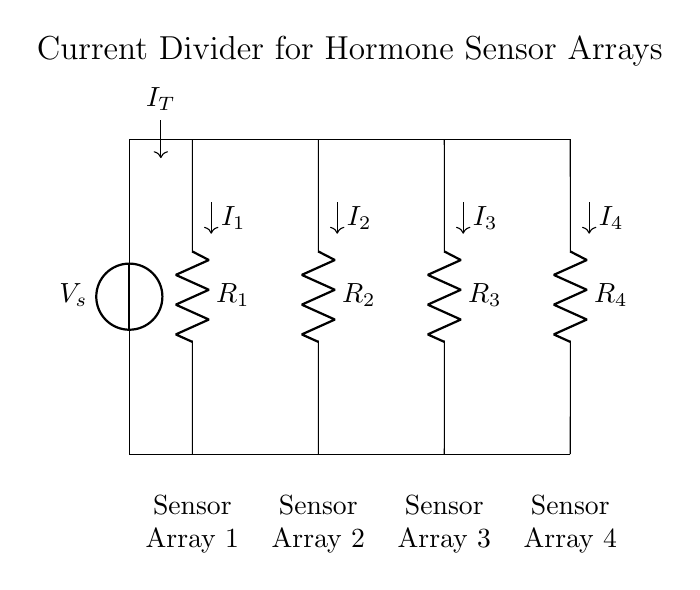What is the total input current in this circuit? The total input current, denoted as It, is the current flowing from the voltage source into the circuit. It is indicated by the arrow labeled I_T.
Answer: I_T What are the resistance values in this circuit? The resistors are labeled R_1, R_2, R_3, and R_4. However, the specific numerical values for these resistances are not provided in the diagram but can be inferred from further context.
Answer: R_1, R_2, R_3, R_4 How many sensor arrays are connected in parallel in this circuit? The circuit contains four parallel branches leading to four sensor arrays, each designated as Sensor Array 1, Sensor Array 2, Sensor Array 3, and Sensor Array 4.
Answer: Four What is the current flowing through R_3? The current flowing through each resistor, including R_3, depends on the resistor values and the total current divided among the branches. Without specific resistance values, we cannot determine the exact value of I_3. An equation based on the current divider rule would generally be used to find this if the values were known.
Answer: I_3 depends on R_3 What do you understand by a current divider in this context? A current divider allows the total input current to be distributed among multiple branches based on their resistance values. In this circuit, the total current flows into all four branches and divides according to the resistances of R_1, R_2, R_3, and R_4, affecting the sensor array readings for hormone detection.
Answer: It divides current Which branches are directly connected to the voltage source? The branches R_1, R_2, R_3, and R_4 are connected in parallel. Each is connected to the top node of the circuit, which is also connected to the voltage source.
Answer: R_1, R_2, R_3, R_4 